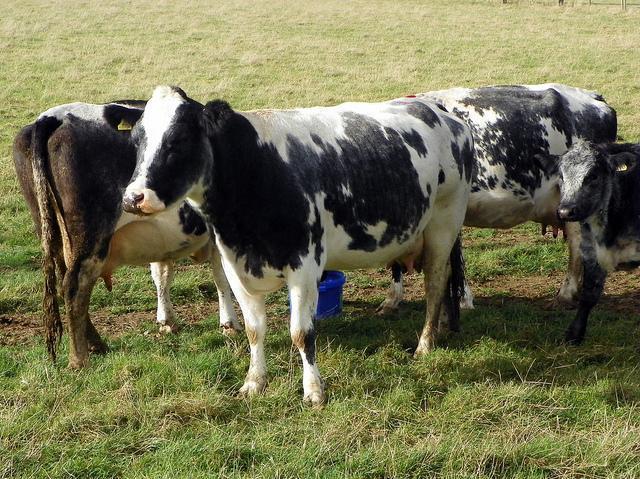Which animal look different than the cows in the picture?
Answer the question by selecting the correct answer among the 4 following choices.
Options: Snake, chicken, goat, pig. Goat. 